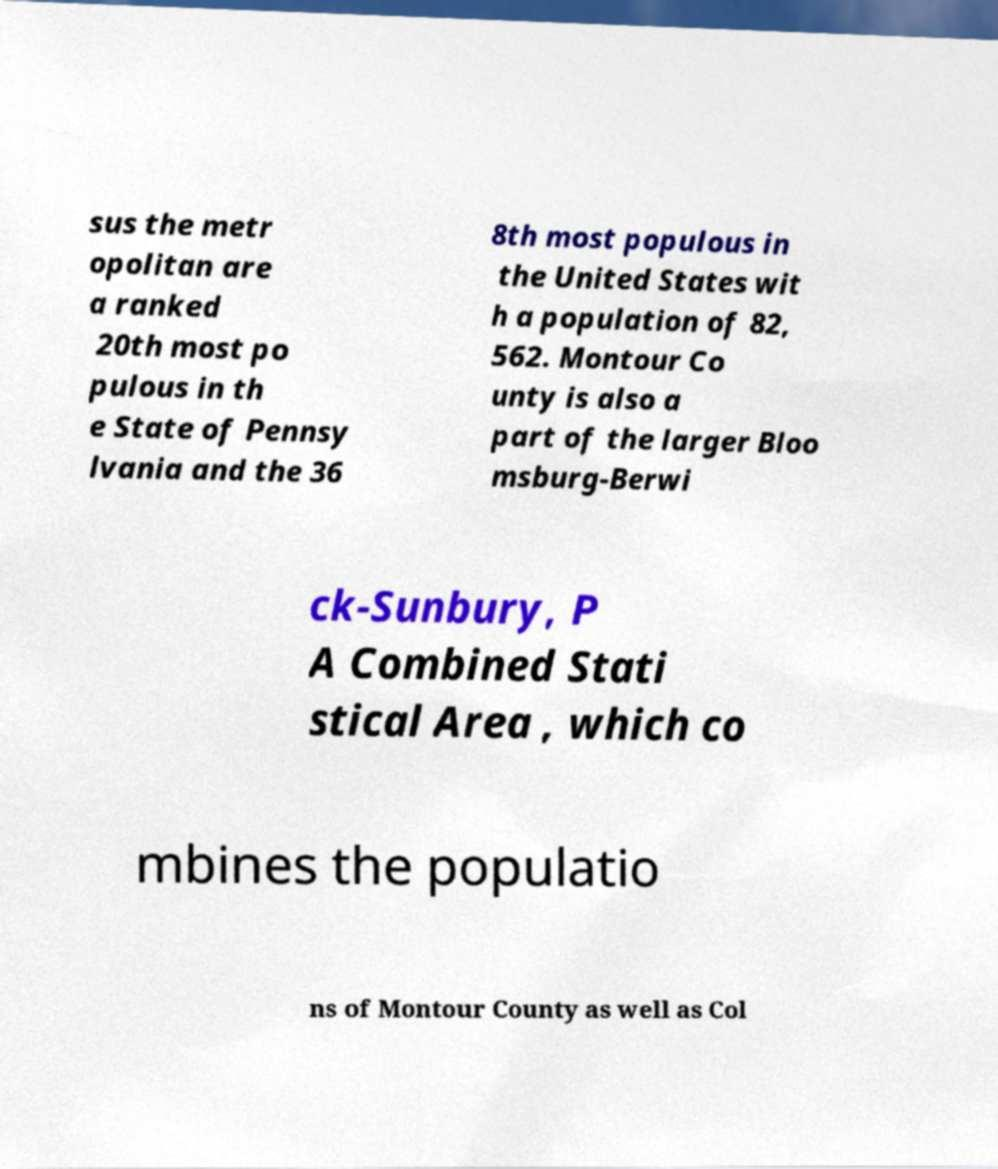I need the written content from this picture converted into text. Can you do that? sus the metr opolitan are a ranked 20th most po pulous in th e State of Pennsy lvania and the 36 8th most populous in the United States wit h a population of 82, 562. Montour Co unty is also a part of the larger Bloo msburg-Berwi ck-Sunbury, P A Combined Stati stical Area , which co mbines the populatio ns of Montour County as well as Col 